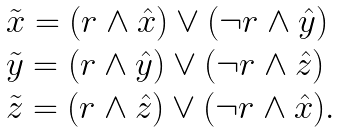Convert formula to latex. <formula><loc_0><loc_0><loc_500><loc_500>\begin{array} { l } \tilde { x } = ( r \wedge \hat { x } ) \vee ( \neg r \wedge \hat { y } ) \\ \tilde { y } = ( r \wedge \hat { y } ) \vee ( \neg r \wedge \hat { z } ) \\ \tilde { z } = ( r \wedge \hat { z } ) \vee ( \neg r \wedge \hat { x } ) . \end{array}</formula> 